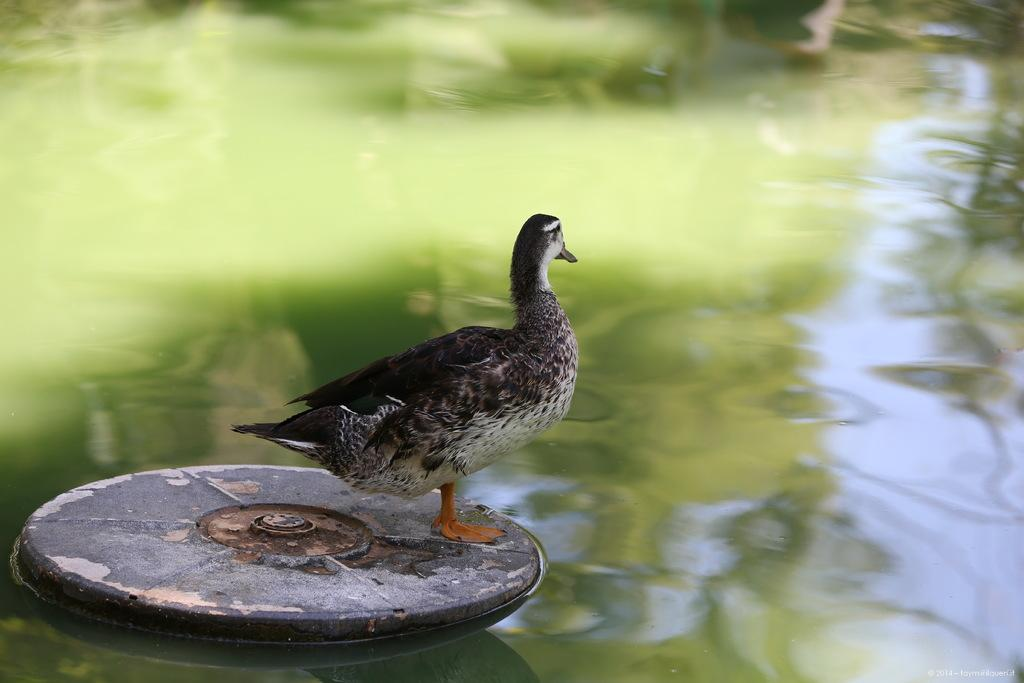What type of animal can be seen in the image? There is a bird in the image. What is the bird standing on? The bird is standing on a board. Where is the board located? The board is present in the water. What is visible in the background of the image? Water is visible in the image. What type of insect can be seen flying around the bird in the image? There is no insect visible in the image; it only features a bird standing on a board in the water. 